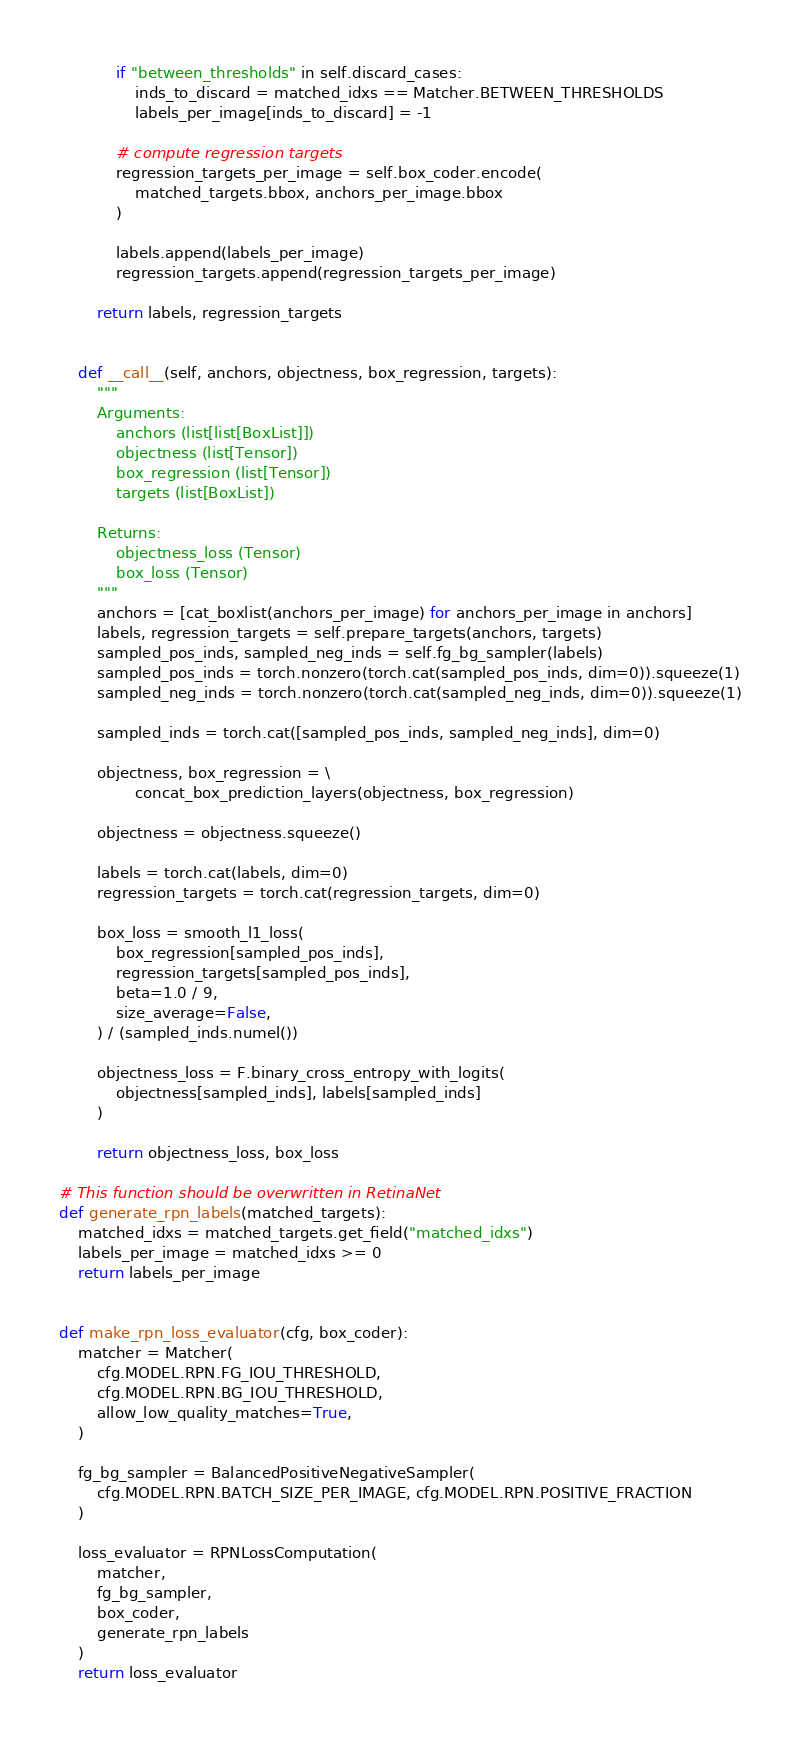Convert code to text. <code><loc_0><loc_0><loc_500><loc_500><_Python_>            if "between_thresholds" in self.discard_cases:
                inds_to_discard = matched_idxs == Matcher.BETWEEN_THRESHOLDS
                labels_per_image[inds_to_discard] = -1

            # compute regression targets
            regression_targets_per_image = self.box_coder.encode(
                matched_targets.bbox, anchors_per_image.bbox
            )

            labels.append(labels_per_image)
            regression_targets.append(regression_targets_per_image)

        return labels, regression_targets


    def __call__(self, anchors, objectness, box_regression, targets):
        """
        Arguments:
            anchors (list[list[BoxList]])
            objectness (list[Tensor])
            box_regression (list[Tensor])
            targets (list[BoxList])

        Returns:
            objectness_loss (Tensor)
            box_loss (Tensor)
        """
        anchors = [cat_boxlist(anchors_per_image) for anchors_per_image in anchors]
        labels, regression_targets = self.prepare_targets(anchors, targets)
        sampled_pos_inds, sampled_neg_inds = self.fg_bg_sampler(labels)
        sampled_pos_inds = torch.nonzero(torch.cat(sampled_pos_inds, dim=0)).squeeze(1)
        sampled_neg_inds = torch.nonzero(torch.cat(sampled_neg_inds, dim=0)).squeeze(1)

        sampled_inds = torch.cat([sampled_pos_inds, sampled_neg_inds], dim=0)

        objectness, box_regression = \
                concat_box_prediction_layers(objectness, box_regression)

        objectness = objectness.squeeze()

        labels = torch.cat(labels, dim=0)
        regression_targets = torch.cat(regression_targets, dim=0)

        box_loss = smooth_l1_loss(
            box_regression[sampled_pos_inds],
            regression_targets[sampled_pos_inds],
            beta=1.0 / 9,
            size_average=False,
        ) / (sampled_inds.numel())

        objectness_loss = F.binary_cross_entropy_with_logits(
            objectness[sampled_inds], labels[sampled_inds]
        )

        return objectness_loss, box_loss

# This function should be overwritten in RetinaNet
def generate_rpn_labels(matched_targets):
    matched_idxs = matched_targets.get_field("matched_idxs")
    labels_per_image = matched_idxs >= 0
    return labels_per_image


def make_rpn_loss_evaluator(cfg, box_coder):
    matcher = Matcher(
        cfg.MODEL.RPN.FG_IOU_THRESHOLD,
        cfg.MODEL.RPN.BG_IOU_THRESHOLD,
        allow_low_quality_matches=True,
    )

    fg_bg_sampler = BalancedPositiveNegativeSampler(
        cfg.MODEL.RPN.BATCH_SIZE_PER_IMAGE, cfg.MODEL.RPN.POSITIVE_FRACTION
    )

    loss_evaluator = RPNLossComputation(
        matcher,
        fg_bg_sampler,
        box_coder,
        generate_rpn_labels
    )
    return loss_evaluator
</code> 